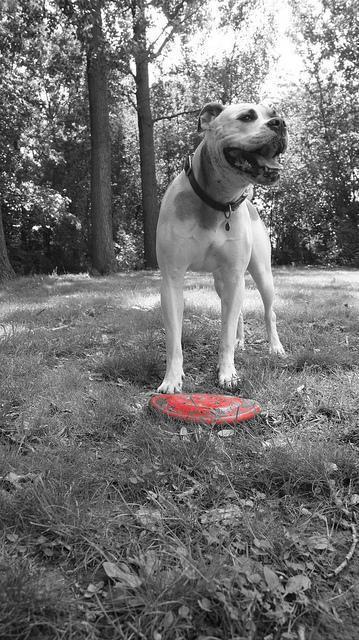How many frisbees can you see?
Give a very brief answer. 1. 